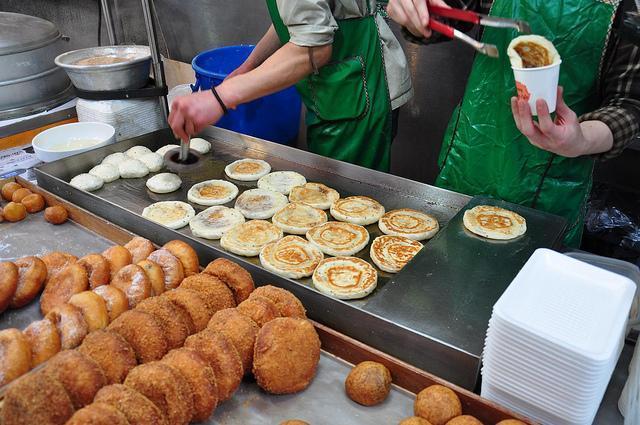How many donuts are there?
Give a very brief answer. 5. How many bowls are visible?
Give a very brief answer. 2. How many people are in the picture?
Give a very brief answer. 2. 